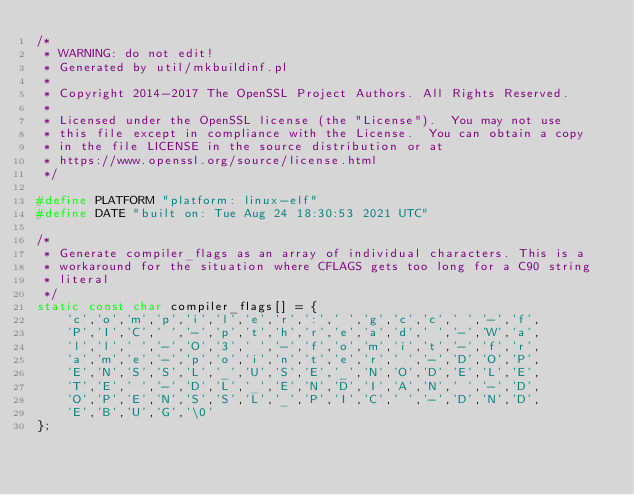<code> <loc_0><loc_0><loc_500><loc_500><_C_>/*
 * WARNING: do not edit!
 * Generated by util/mkbuildinf.pl
 *
 * Copyright 2014-2017 The OpenSSL Project Authors. All Rights Reserved.
 *
 * Licensed under the OpenSSL license (the "License").  You may not use
 * this file except in compliance with the License.  You can obtain a copy
 * in the file LICENSE in the source distribution or at
 * https://www.openssl.org/source/license.html
 */

#define PLATFORM "platform: linux-elf"
#define DATE "built on: Tue Aug 24 18:30:53 2021 UTC"

/*
 * Generate compiler_flags as an array of individual characters. This is a
 * workaround for the situation where CFLAGS gets too long for a C90 string
 * literal
 */
static const char compiler_flags[] = {
    'c','o','m','p','i','l','e','r',':',' ','g','c','c',' ','-','f',
    'P','I','C',' ','-','p','t','h','r','e','a','d',' ','-','W','a',
    'l','l',' ','-','O','3',' ','-','f','o','m','i','t','-','f','r',
    'a','m','e','-','p','o','i','n','t','e','r',' ','-','D','O','P',
    'E','N','S','S','L','_','U','S','E','_','N','O','D','E','L','E',
    'T','E',' ','-','D','L','_','E','N','D','I','A','N',' ','-','D',
    'O','P','E','N','S','S','L','_','P','I','C',' ','-','D','N','D',
    'E','B','U','G','\0'
};
</code> 